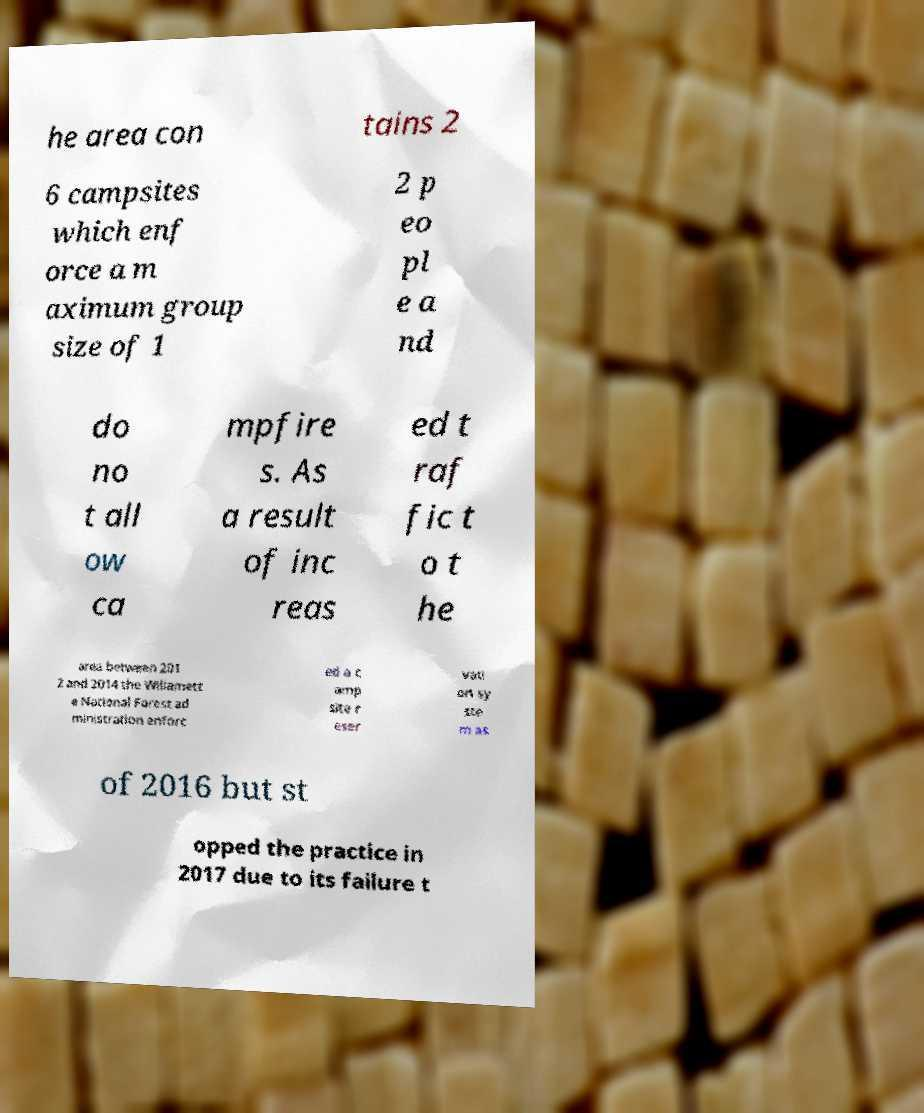Can you accurately transcribe the text from the provided image for me? he area con tains 2 6 campsites which enf orce a m aximum group size of 1 2 p eo pl e a nd do no t all ow ca mpfire s. As a result of inc reas ed t raf fic t o t he area between 201 2 and 2014 the Willamett e National Forest ad ministration enforc ed a c amp site r eser vati on sy ste m as of 2016 but st opped the practice in 2017 due to its failure t 